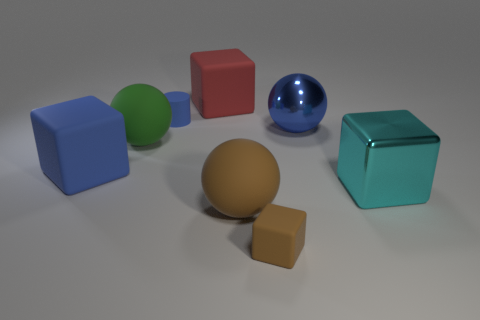Do the ball in front of the cyan block and the ball that is to the right of the large brown ball have the same material?
Your answer should be very brief. No. There is a large blue object that is left of the small blue rubber thing; are there any blue matte things that are behind it?
Make the answer very short. Yes. There is a cylinder that is made of the same material as the large green thing; what is its color?
Offer a terse response. Blue. Are there more cylinders than tiny blue rubber cubes?
Offer a very short reply. Yes. What number of things are either big metal objects that are behind the green rubber thing or matte spheres?
Your response must be concise. 3. Are there any brown objects that have the same size as the blue rubber cylinder?
Your answer should be compact. Yes. Are there fewer big matte balls than blue objects?
Offer a very short reply. Yes. What number of cylinders are either large red things or small brown things?
Make the answer very short. 0. How many large metallic things are the same color as the big metallic block?
Provide a succinct answer. 0. There is a cube that is on the right side of the big red block and behind the large brown ball; how big is it?
Provide a succinct answer. Large. 